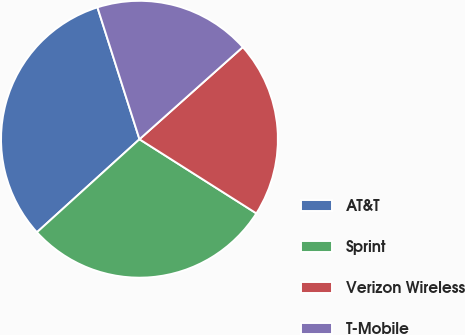Convert chart. <chart><loc_0><loc_0><loc_500><loc_500><pie_chart><fcel>AT&T<fcel>Sprint<fcel>Verizon Wireless<fcel>T-Mobile<nl><fcel>31.82%<fcel>29.28%<fcel>20.59%<fcel>18.32%<nl></chart> 